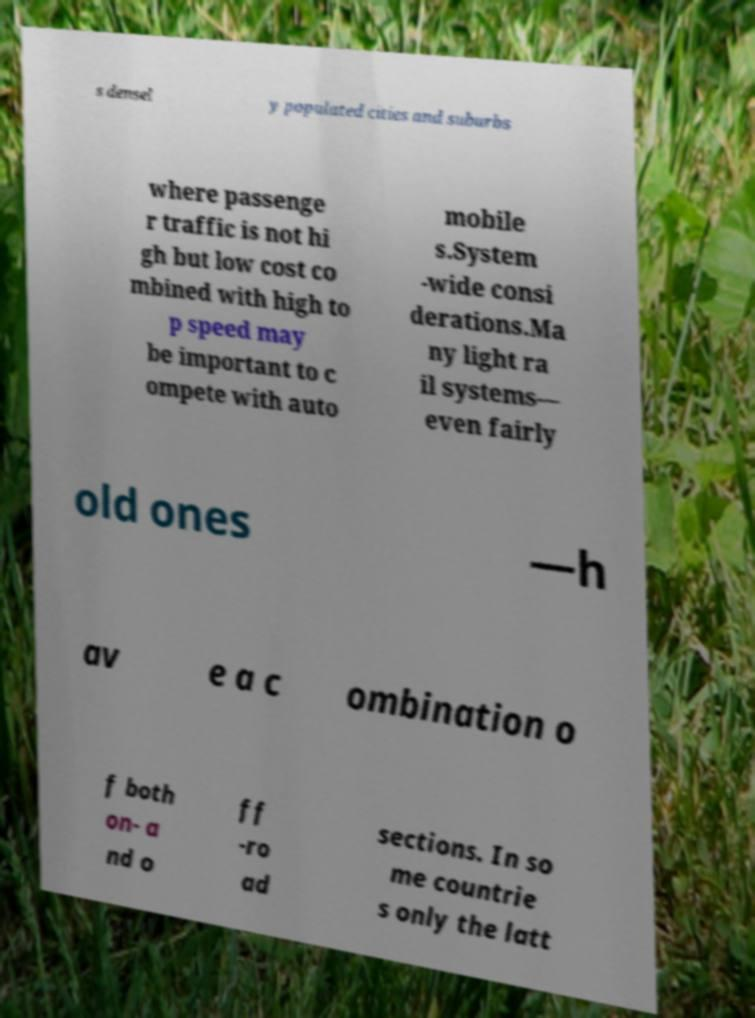Please read and relay the text visible in this image. What does it say? s densel y populated cities and suburbs where passenge r traffic is not hi gh but low cost co mbined with high to p speed may be important to c ompete with auto mobile s.System -wide consi derations.Ma ny light ra il systems— even fairly old ones —h av e a c ombination o f both on- a nd o ff -ro ad sections. In so me countrie s only the latt 